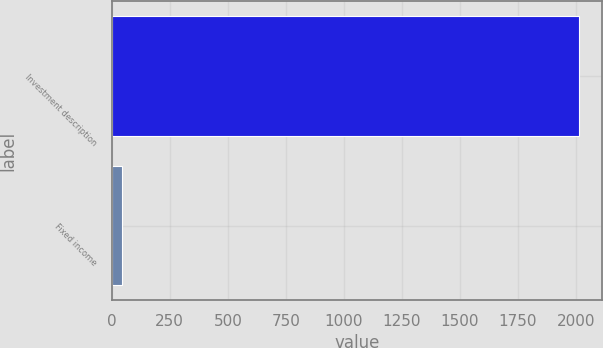Convert chart. <chart><loc_0><loc_0><loc_500><loc_500><bar_chart><fcel>Investment description<fcel>Fixed income<nl><fcel>2012<fcel>45<nl></chart> 